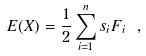Convert formula to latex. <formula><loc_0><loc_0><loc_500><loc_500>E ( X ) = \frac { 1 } { 2 } \sum _ { i = 1 } ^ { n } s _ { i } F _ { i } \ ,</formula> 